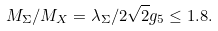<formula> <loc_0><loc_0><loc_500><loc_500>M _ { \Sigma } / M _ { X } = \lambda _ { \Sigma } / 2 \sqrt { 2 } g _ { 5 } \leq 1 . 8 .</formula> 